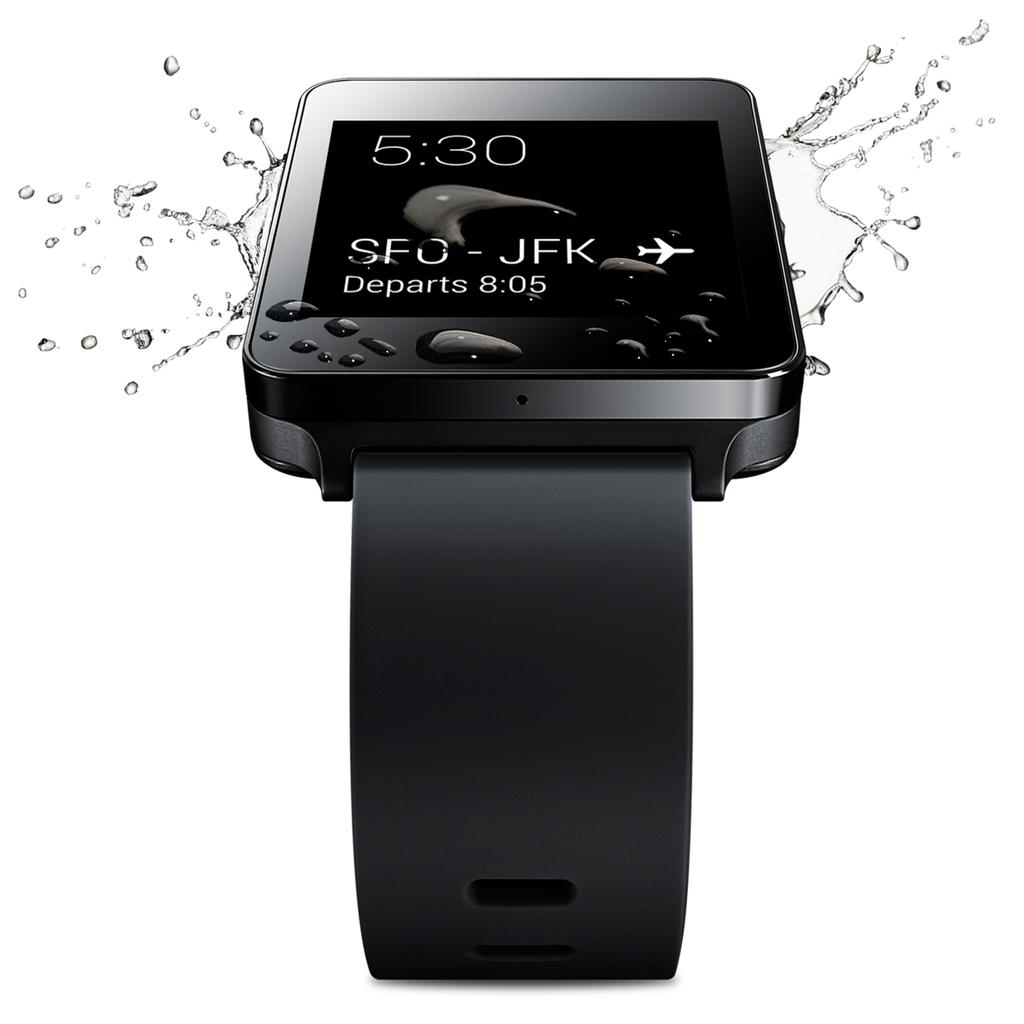<image>
Offer a succinct explanation of the picture presented. Flight information on a screen shows a departure time of 8:05. 